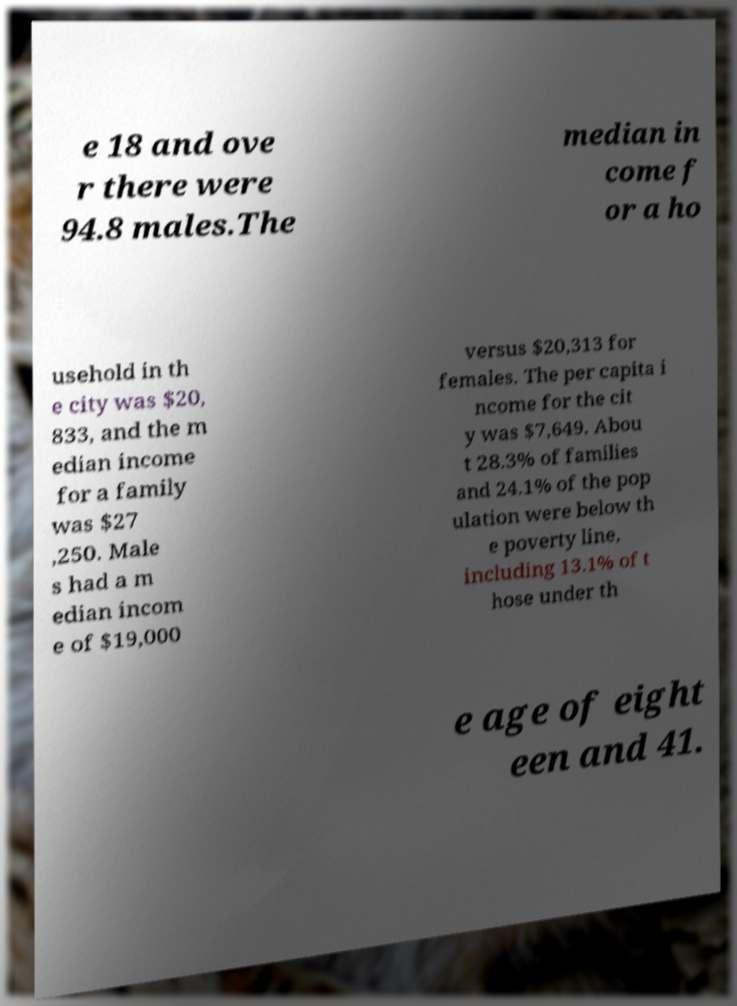Can you read and provide the text displayed in the image?This photo seems to have some interesting text. Can you extract and type it out for me? e 18 and ove r there were 94.8 males.The median in come f or a ho usehold in th e city was $20, 833, and the m edian income for a family was $27 ,250. Male s had a m edian incom e of $19,000 versus $20,313 for females. The per capita i ncome for the cit y was $7,649. Abou t 28.3% of families and 24.1% of the pop ulation were below th e poverty line, including 13.1% of t hose under th e age of eight een and 41. 